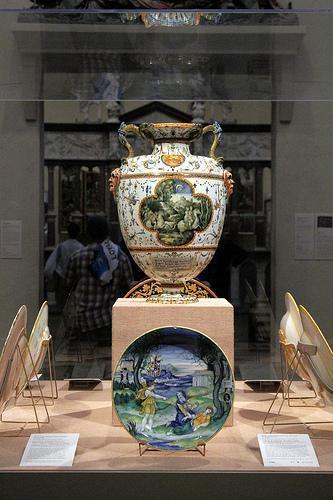How many vases are there?
Give a very brief answer. 1. 